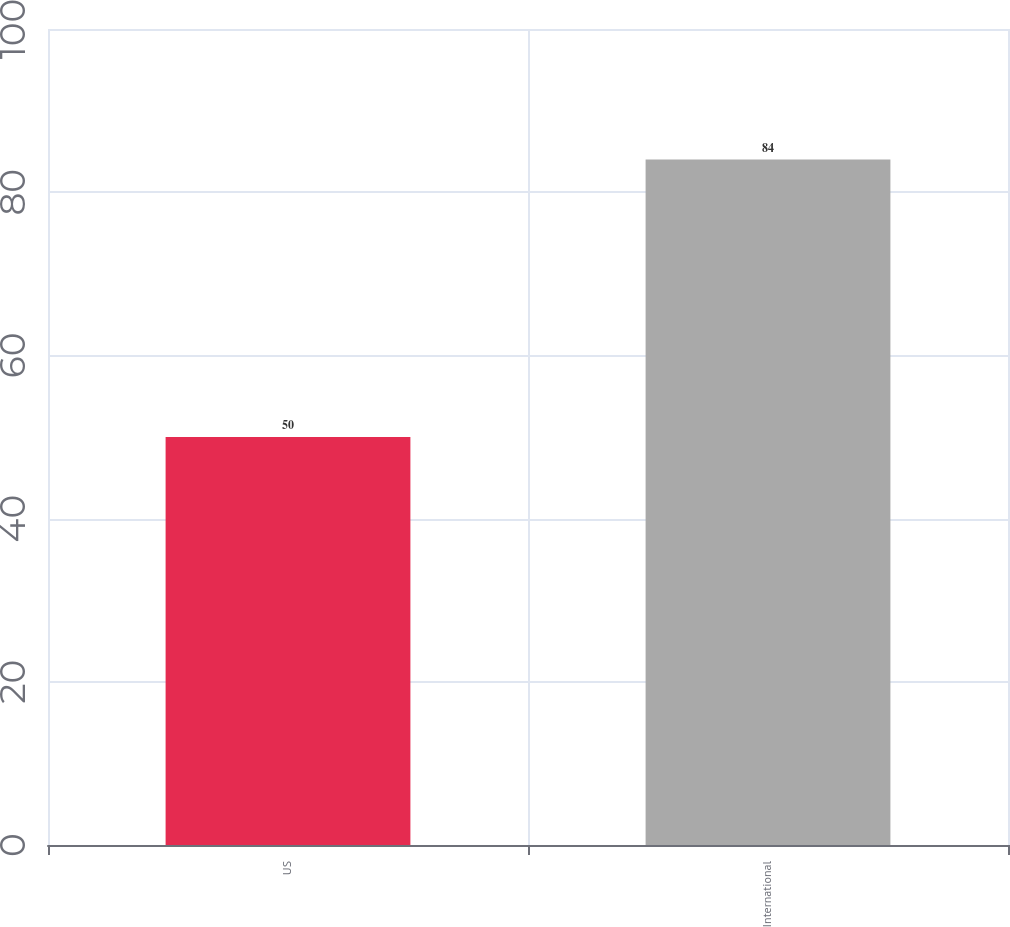<chart> <loc_0><loc_0><loc_500><loc_500><bar_chart><fcel>US<fcel>International<nl><fcel>50<fcel>84<nl></chart> 